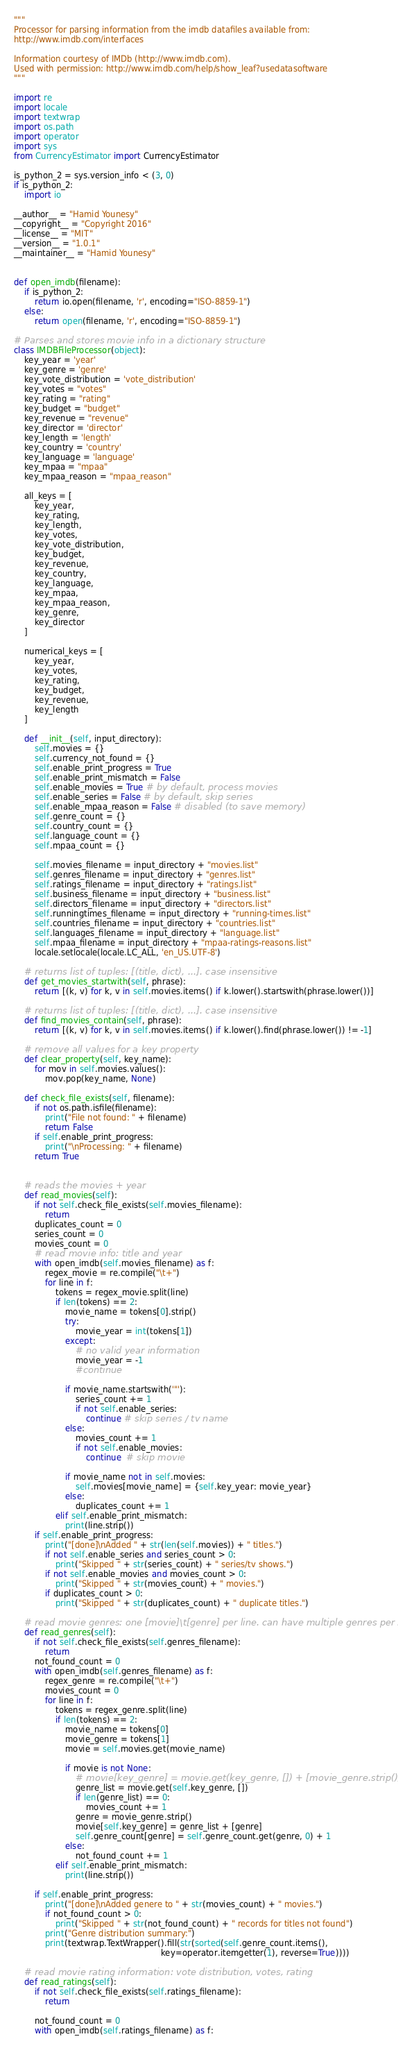Convert code to text. <code><loc_0><loc_0><loc_500><loc_500><_Python_>"""
Processor for parsing information from the imdb datafiles available from:
http://www.imdb.com/interfaces

Information courtesy of IMDb (http://www.imdb.com).
Used with permission: http://www.imdb.com/help/show_leaf?usedatasoftware
"""

import re
import locale
import textwrap
import os.path
import operator
import sys
from CurrencyEstimator import CurrencyEstimator

is_python_2 = sys.version_info < (3, 0)
if is_python_2:
    import io

__author__ = "Hamid Younesy"
__copyright__ = "Copyright 2016"
__license__ = "MIT"
__version__ = "1.0.1"
__maintainer__ = "Hamid Younesy"


def open_imdb(filename):
    if is_python_2:
        return io.open(filename, 'r', encoding="ISO-8859-1")
    else:
        return open(filename, 'r', encoding="ISO-8859-1")

# Parses and stores movie info in a dictionary structure
class IMDBFileProcessor(object):
    key_year = 'year'
    key_genre = 'genre'
    key_vote_distribution = 'vote_distribution'
    key_votes = "votes"
    key_rating = "rating"
    key_budget = "budget"
    key_revenue = "revenue"
    key_director = 'director'
    key_length = 'length'
    key_country = 'country'
    key_language = 'language'
    key_mpaa = "mpaa"
    key_mpaa_reason = "mpaa_reason"

    all_keys = [
        key_year,
        key_rating,
        key_length,
        key_votes,
        key_vote_distribution,
        key_budget,
        key_revenue,
        key_country,
        key_language,
        key_mpaa,
        key_mpaa_reason,
        key_genre,
        key_director
    ]

    numerical_keys = [
        key_year,
        key_votes,
        key_rating,
        key_budget,
        key_revenue,
        key_length
    ]

    def __init__(self, input_directory):
        self.movies = {}
        self.currency_not_found = {}
        self.enable_print_progress = True
        self.enable_print_mismatch = False
        self.enable_movies = True # by default, process movies
        self.enable_series = False # by default, skip series
        self.enable_mpaa_reason = False # disabled (to save memory)
        self.genre_count = {}
        self.country_count = {}
        self.language_count = {}
        self.mpaa_count = {}

        self.movies_filename = input_directory + "movies.list"
        self.genres_filename = input_directory + "genres.list"
        self.ratings_filename = input_directory + "ratings.list"
        self.business_filename = input_directory + "business.list"
        self.directors_filename = input_directory + "directors.list"
        self.runningtimes_filename = input_directory + "running-times.list"
        self.countries_filename = input_directory + "countries.list"
        self.languages_filename = input_directory + "language.list"
        self.mpaa_filename = input_directory + "mpaa-ratings-reasons.list"
        locale.setlocale(locale.LC_ALL, 'en_US.UTF-8')

    # returns list of tuples: [(title, dict), ...]. case insensitive
    def get_movies_startwith(self, phrase):
        return [(k, v) for k, v in self.movies.items() if k.lower().startswith(phrase.lower())]

    # returns list of tuples: [(title, dict), ...]. case insensitive
    def find_movies_contain(self, phrase):
        return [(k, v) for k, v in self.movies.items() if k.lower().find(phrase.lower()) != -1]

    # remove all values for a key property
    def clear_property(self, key_name):
        for mov in self.movies.values():
            mov.pop(key_name, None)

    def check_file_exists(self, filename):
        if not os.path.isfile(filename):
            print("File not found: " + filename)
            return False
        if self.enable_print_progress:
            print("\nProcessing: " + filename)
        return True


    # reads the movies + year
    def read_movies(self):
        if not self.check_file_exists(self.movies_filename):
            return
        duplicates_count = 0
        series_count = 0
        movies_count = 0
        # read movie info: title and year
        with open_imdb(self.movies_filename) as f:
            regex_movie = re.compile("\t+")
            for line in f:
                tokens = regex_movie.split(line)
                if len(tokens) == 2:
                    movie_name = tokens[0].strip()
                    try:
                        movie_year = int(tokens[1])
                    except:
                        # no valid year information
                        movie_year = -1
                        #continue

                    if movie_name.startswith('"'):
                        series_count += 1
                        if not self.enable_series:
                            continue # skip series / tv name
                    else:
                        movies_count += 1
                        if not self.enable_movies:
                            continue  # skip movie

                    if movie_name not in self.movies:
                        self.movies[movie_name] = {self.key_year: movie_year}
                    else:
                        duplicates_count += 1
                elif self.enable_print_mismatch:
                    print(line.strip())
        if self.enable_print_progress:
            print("[done]\nAdded " + str(len(self.movies)) + " titles.")
            if not self.enable_series and series_count > 0:
                print("Skipped " + str(series_count) + " series/tv shows.")
            if not self.enable_movies and movies_count > 0:
                print("Skipped " + str(movies_count) + " movies.")
            if duplicates_count > 0:
                print("Skipped " + str(duplicates_count) + " duplicate titles.")

    # read movie genres: one [movie]\t[genre] per line. can have multiple genres per movie
    def read_genres(self):
        if not self.check_file_exists(self.genres_filename):
            return
        not_found_count = 0
        with open_imdb(self.genres_filename) as f:
            regex_genre = re.compile("\t+")
            movies_count = 0
            for line in f:
                tokens = regex_genre.split(line)
                if len(tokens) == 2:
                    movie_name = tokens[0]
                    movie_genre = tokens[1]
                    movie = self.movies.get(movie_name)

                    if movie is not None:
                        # movie[key_genre] = movie.get(key_genre, []) + [movie_genre.strip()]
                        genre_list = movie.get(self.key_genre, [])
                        if len(genre_list) == 0:
                            movies_count += 1
                        genre = movie_genre.strip()
                        movie[self.key_genre] = genre_list + [genre]
                        self.genre_count[genre] = self.genre_count.get(genre, 0) + 1
                    else:
                        not_found_count += 1
                elif self.enable_print_mismatch:
                    print(line.strip())

        if self.enable_print_progress:
            print("[done]\nAdded genere to " + str(movies_count) + " movies.")
            if not_found_count > 0:
                print("Skipped " + str(not_found_count) + " records for titles not found")
            print("Genre distribution summary:")
            print(textwrap.TextWrapper().fill(str(sorted(self.genre_count.items(),
                                                         key=operator.itemgetter(1), reverse=True))))

    # read movie rating information: vote distribution, votes, rating
    def read_ratings(self):
        if not self.check_file_exists(self.ratings_filename):
            return

        not_found_count = 0
        with open_imdb(self.ratings_filename) as f:</code> 